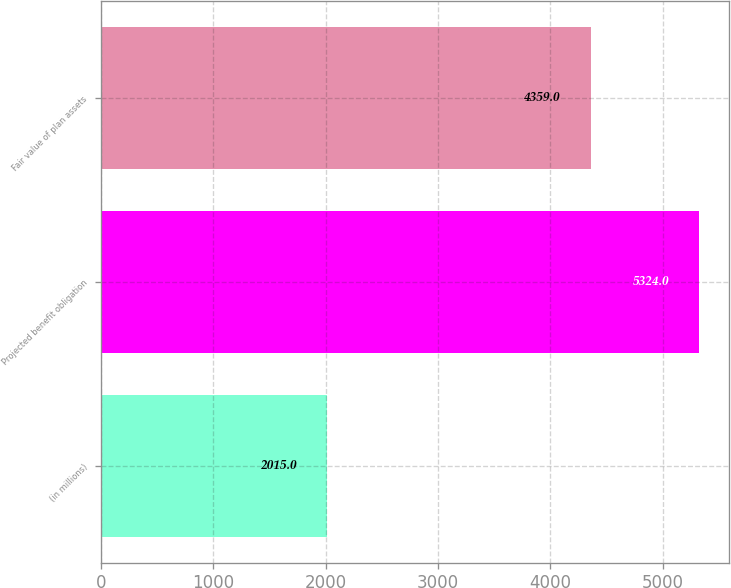Convert chart to OTSL. <chart><loc_0><loc_0><loc_500><loc_500><bar_chart><fcel>(in millions)<fcel>Projected benefit obligation<fcel>Fair value of plan assets<nl><fcel>2015<fcel>5324<fcel>4359<nl></chart> 